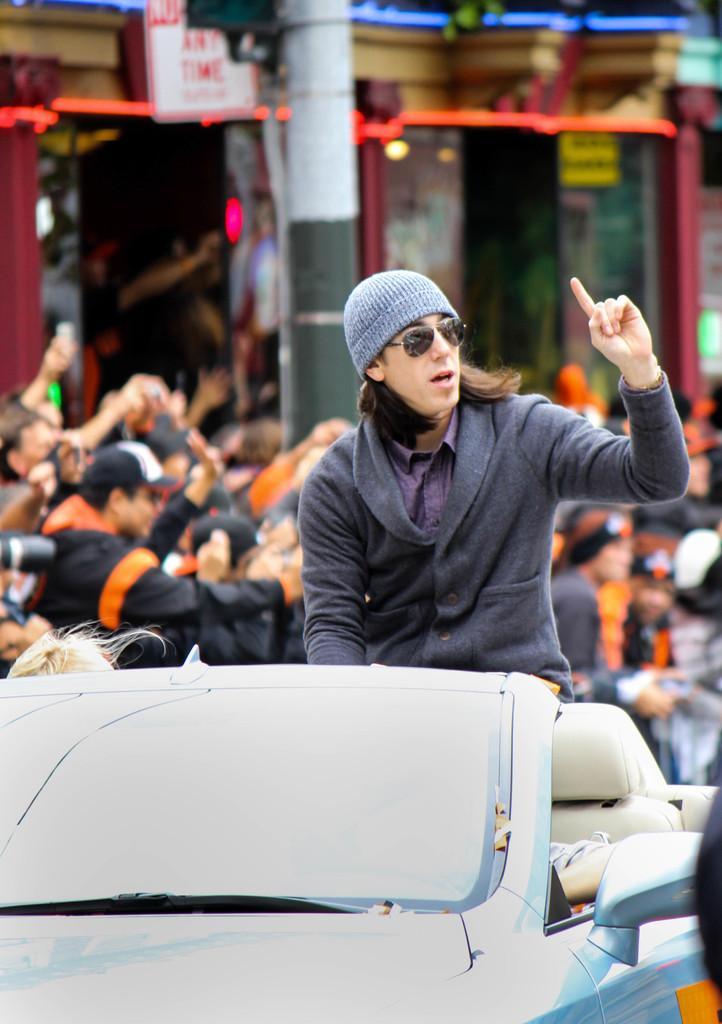Please provide a concise description of this image. People are standing,person is sitting in the car and here there is pole. 